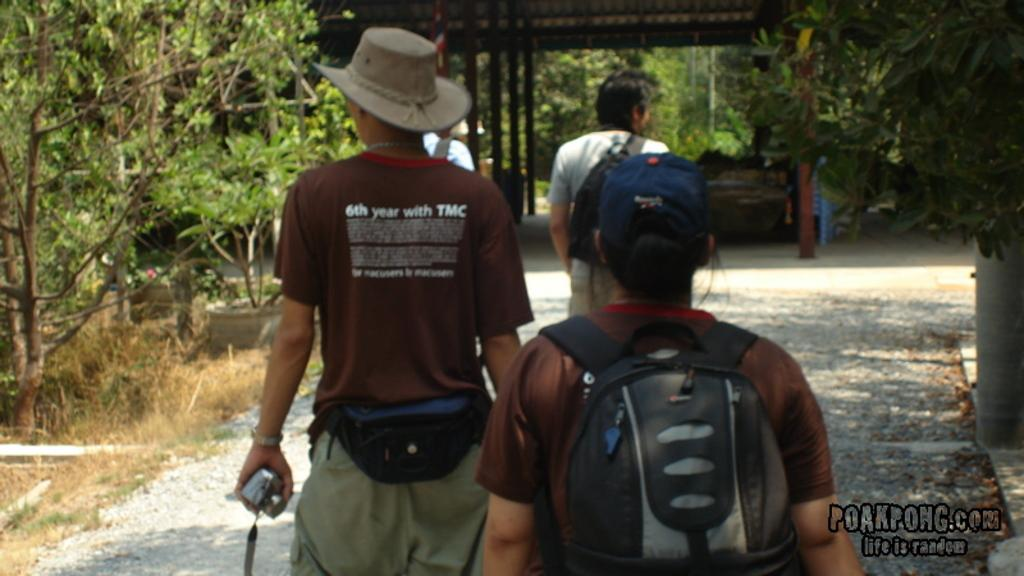How many people are walking in the image? There are four persons walking in the image. Can you describe any accessories or items carried by the people? One person is wearing a backpack bag, and another person is holding a camera in his hand. What type of natural environment can be seen in the image? There are trees visible in the image. What structure can be seen in the background? There is a shelter in the background of the image. What type of fuel is being used by the man in the image? There is no man or fuel present in the image. How many chickens are visible in the image? There are no chickens present in the image. 